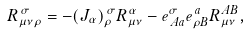<formula> <loc_0><loc_0><loc_500><loc_500>R _ { \mu \nu \rho } ^ { \, \sigma } = - ( J _ { \alpha } ) _ { \rho } ^ { \, \sigma } R _ { \mu \nu } ^ { \alpha } - e ^ { \sigma } _ { \, A a } e _ { \rho B } ^ { \, a } R _ { \mu \nu } ^ { A B } ,</formula> 